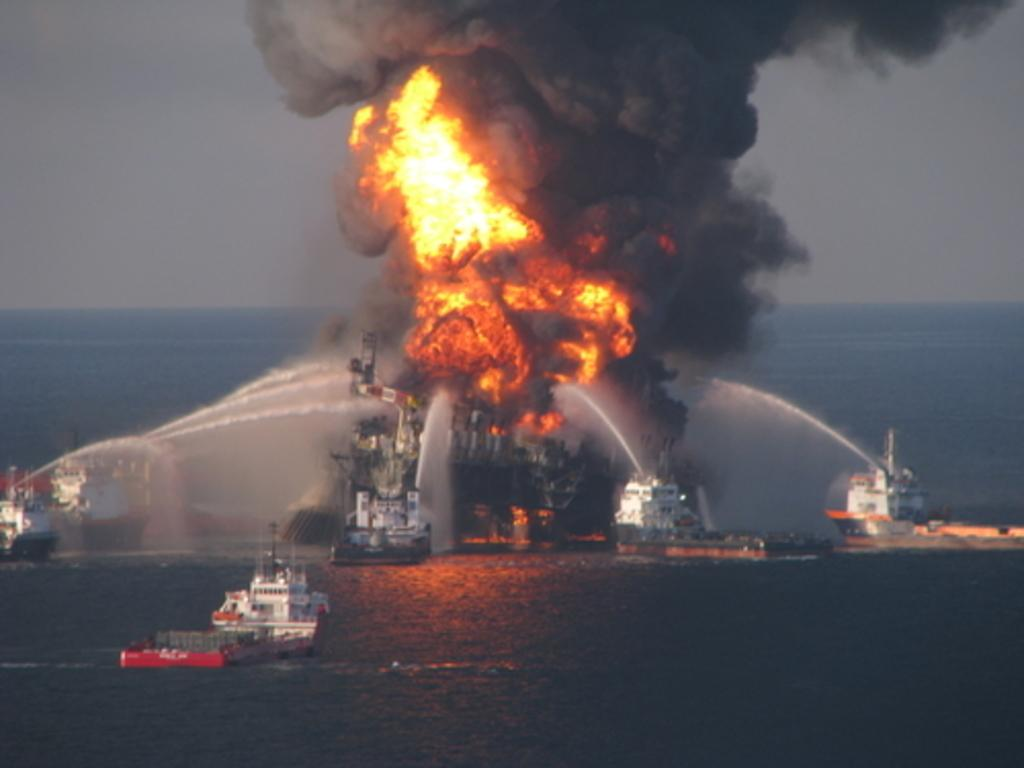What is the main subject of the image? The main subject of the image is ships. Where are the ships located? The ships are on the sea. What are the ships doing in the image? The ships are spraying water. What is the purpose of the water being sprayed in the image? The water is being sprayed on a fire. How many weeks does it take for the father to finish his curve in the image? There is no father or curve present in the image, so this question cannot be answered. 